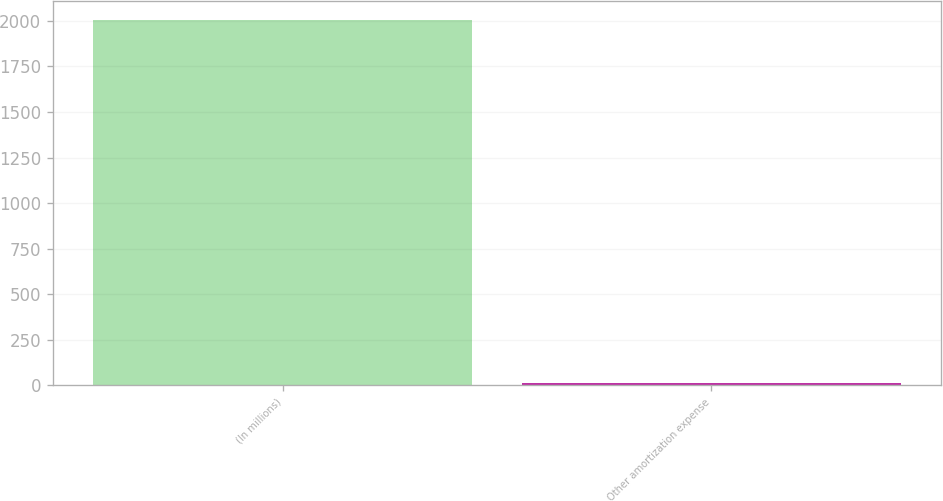Convert chart to OTSL. <chart><loc_0><loc_0><loc_500><loc_500><bar_chart><fcel>(In millions)<fcel>Other amortization expense<nl><fcel>2006<fcel>15<nl></chart> 